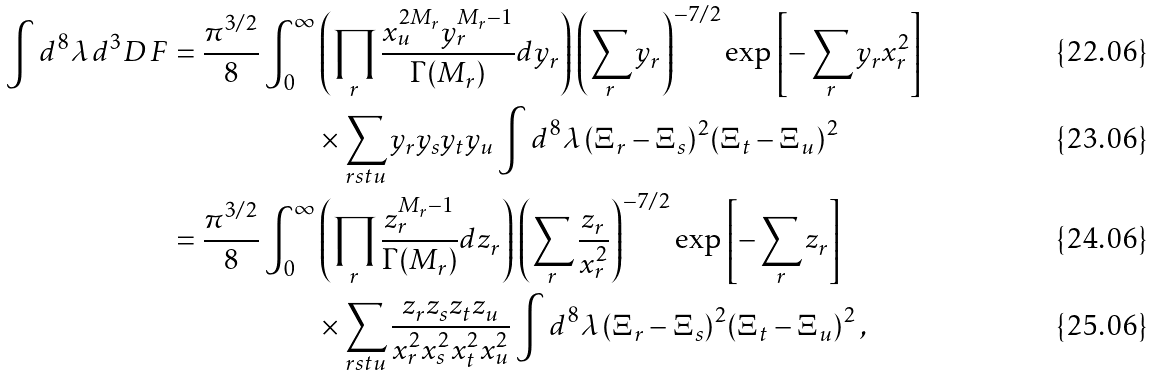Convert formula to latex. <formula><loc_0><loc_0><loc_500><loc_500>\int d ^ { 8 } \lambda \, d ^ { 3 } D \, F = \frac { \pi ^ { 3 / 2 } } { 8 } \int _ { 0 } ^ { \infty } & \left ( \prod _ { r } \frac { x _ { u } ^ { 2 M _ { r } } y _ { r } ^ { M _ { r } - 1 } } { \Gamma ( M _ { r } ) } d y _ { r } \right ) \left ( \sum _ { r } y _ { r } \right ) ^ { - 7 / 2 } \exp \left [ - \sum _ { r } y _ { r } x _ { r } ^ { 2 } \right ] \\ & \times \sum _ { r s t u } y _ { r } y _ { s } y _ { t } y _ { u } \int d ^ { 8 } \lambda \, ( \Xi _ { r } - \Xi _ { s } ) ^ { 2 } ( \Xi _ { t } - \Xi _ { u } ) ^ { 2 } \\ = \frac { \pi ^ { 3 / 2 } } { 8 } \int _ { 0 } ^ { \infty } & \left ( \prod _ { r } \frac { z _ { r } ^ { M _ { r } - 1 } } { \Gamma ( M _ { r } ) } d z _ { r } \right ) \left ( \sum _ { r } \frac { z _ { r } } { x _ { r } ^ { 2 } } \right ) ^ { - 7 / 2 } \exp \left [ - \sum _ { r } z _ { r } \right ] \\ & \times \sum _ { r s t u } \frac { z _ { r } z _ { s } z _ { t } z _ { u } } { x _ { r } ^ { 2 } x _ { s } ^ { 2 } x _ { t } ^ { 2 } x _ { u } ^ { 2 } } \int d ^ { 8 } \lambda \, ( \Xi _ { r } - \Xi _ { s } ) ^ { 2 } ( \Xi _ { t } - \Xi _ { u } ) ^ { 2 } \, ,</formula> 